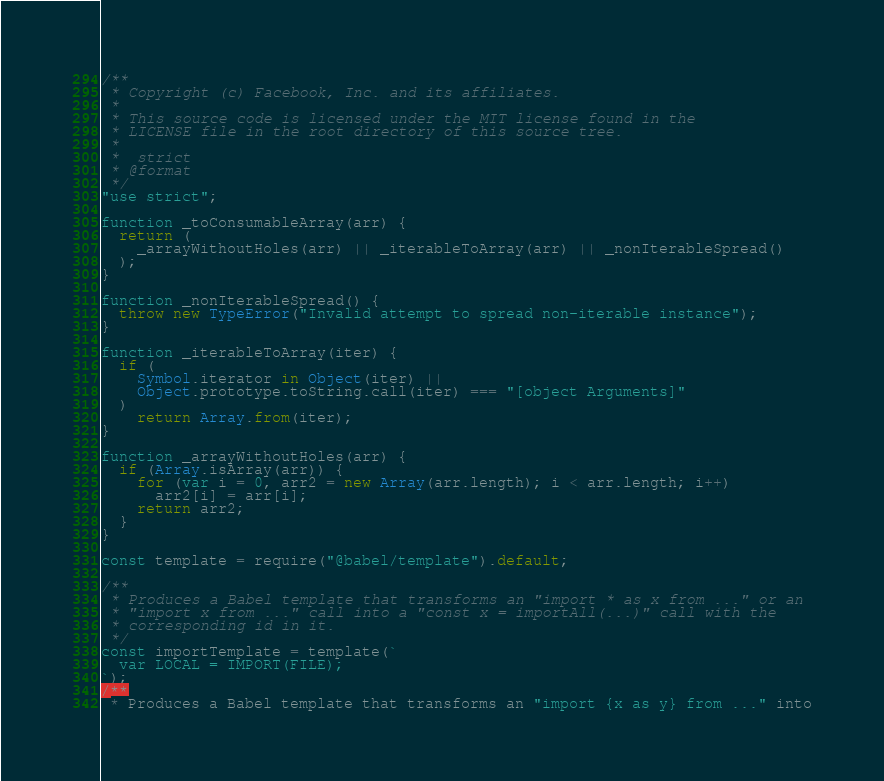Convert code to text. <code><loc_0><loc_0><loc_500><loc_500><_JavaScript_>/**
 * Copyright (c) Facebook, Inc. and its affiliates.
 *
 * This source code is licensed under the MIT license found in the
 * LICENSE file in the root directory of this source tree.
 *
 *  strict
 * @format
 */
"use strict";

function _toConsumableArray(arr) {
  return (
    _arrayWithoutHoles(arr) || _iterableToArray(arr) || _nonIterableSpread()
  );
}

function _nonIterableSpread() {
  throw new TypeError("Invalid attempt to spread non-iterable instance");
}

function _iterableToArray(iter) {
  if (
    Symbol.iterator in Object(iter) ||
    Object.prototype.toString.call(iter) === "[object Arguments]"
  )
    return Array.from(iter);
}

function _arrayWithoutHoles(arr) {
  if (Array.isArray(arr)) {
    for (var i = 0, arr2 = new Array(arr.length); i < arr.length; i++)
      arr2[i] = arr[i];
    return arr2;
  }
}

const template = require("@babel/template").default;

/**
 * Produces a Babel template that transforms an "import * as x from ..." or an
 * "import x from ..." call into a "const x = importAll(...)" call with the
 * corresponding id in it.
 */
const importTemplate = template(`
  var LOCAL = IMPORT(FILE);
`);
/**
 * Produces a Babel template that transforms an "import {x as y} from ..." into</code> 